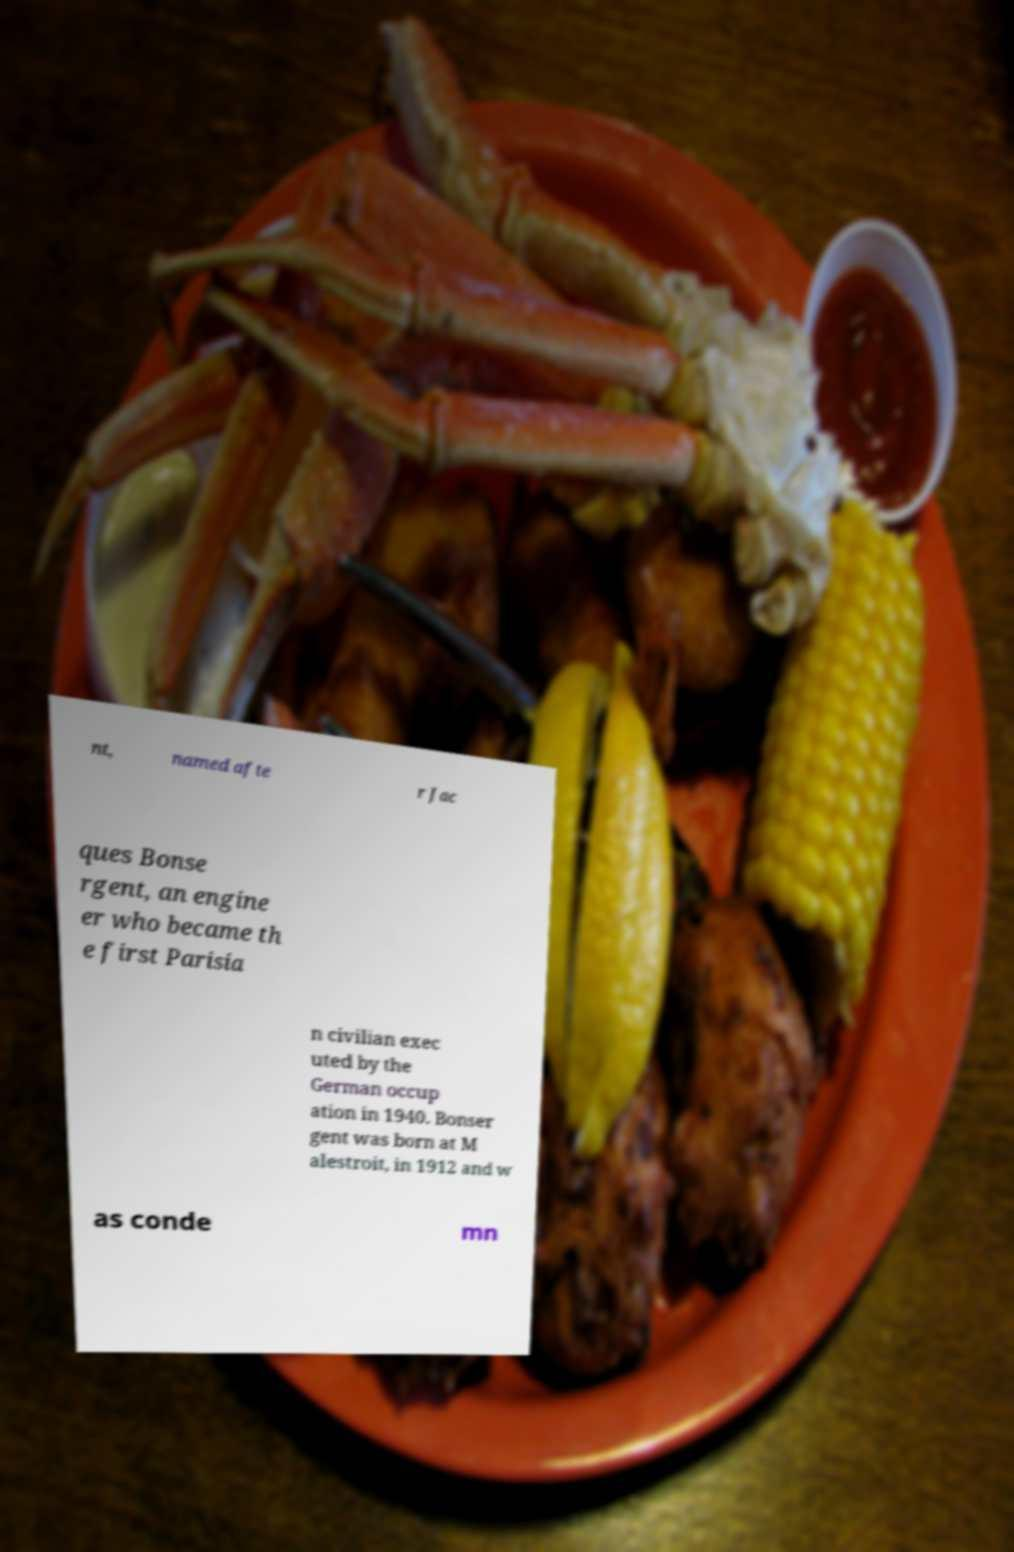Please identify and transcribe the text found in this image. nt, named afte r Jac ques Bonse rgent, an engine er who became th e first Parisia n civilian exec uted by the German occup ation in 1940. Bonser gent was born at M alestroit, in 1912 and w as conde mn 